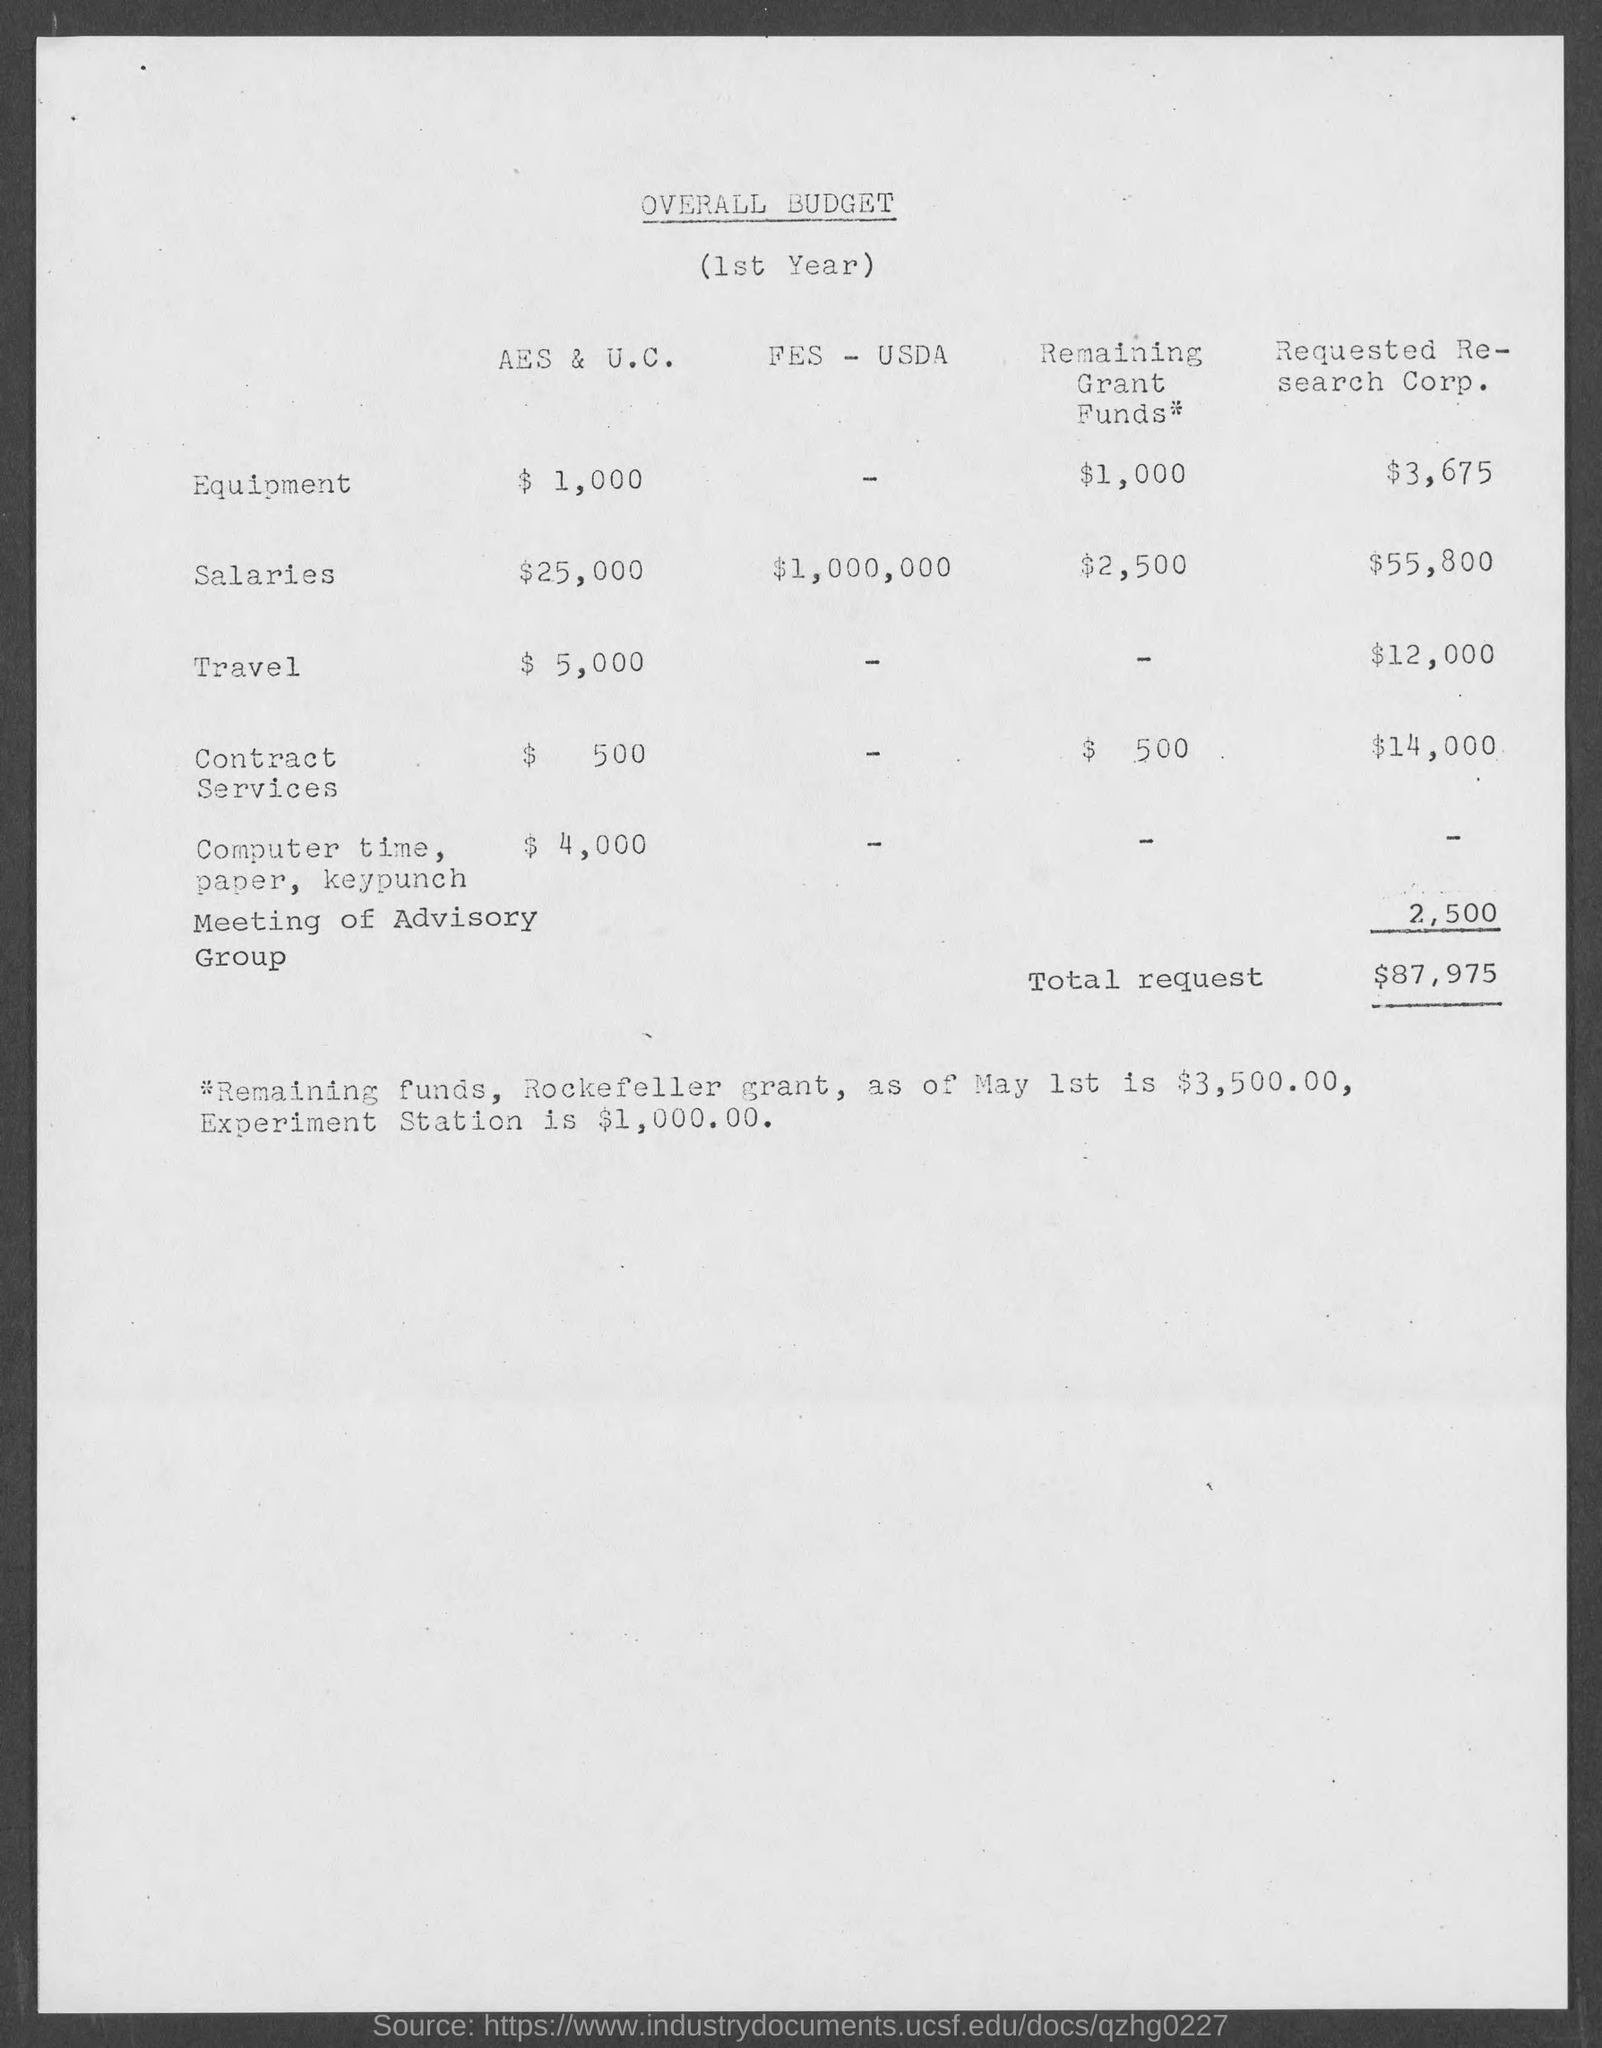Highlight a few significant elements in this photo. The cost of contract services for Requested Research Corporation is $14,000. The cost of travel for AES & U.C. is estimated to be $5,000. The overall budget of the document is unknown. The total request is $87,975. The cost of equipment for AES & U.C. is $1,000. 